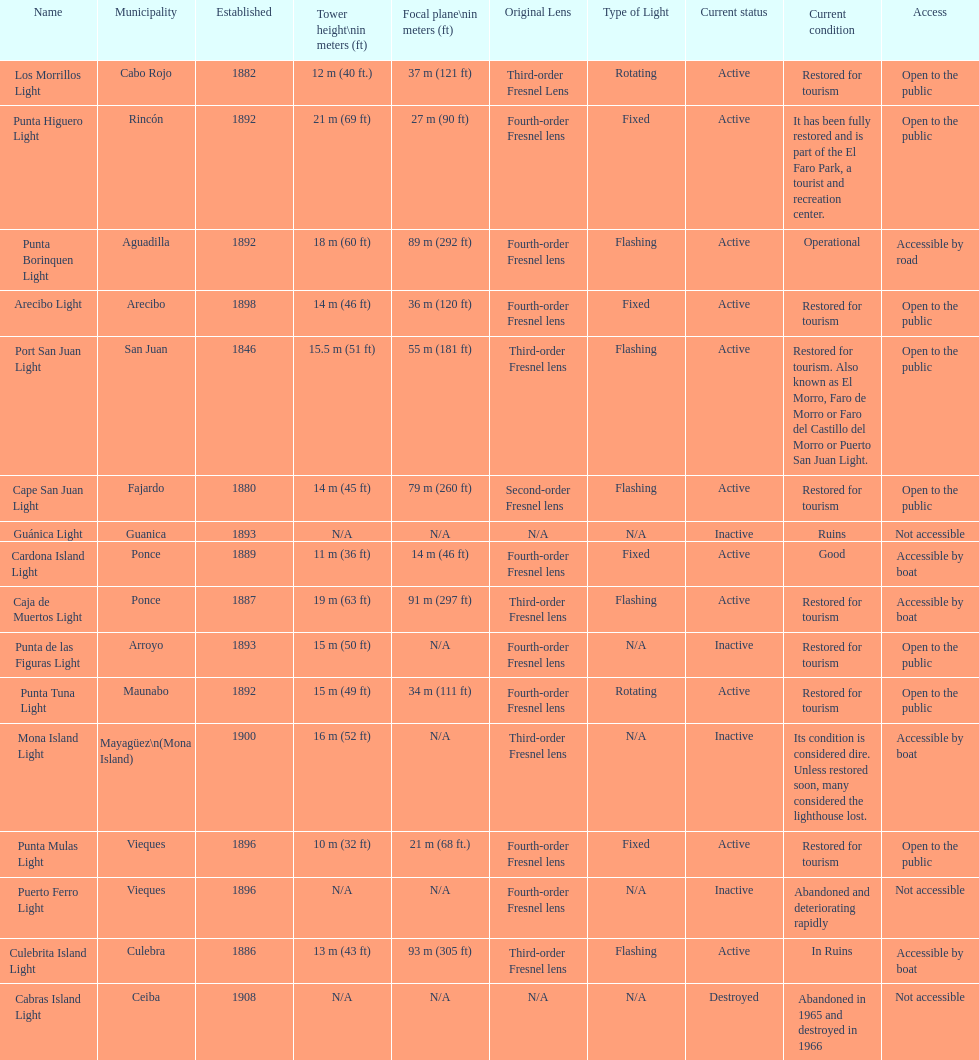How many towers are at least 18 meters tall? 3. 